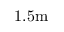<formula> <loc_0><loc_0><loc_500><loc_500>1 . 5 m</formula> 